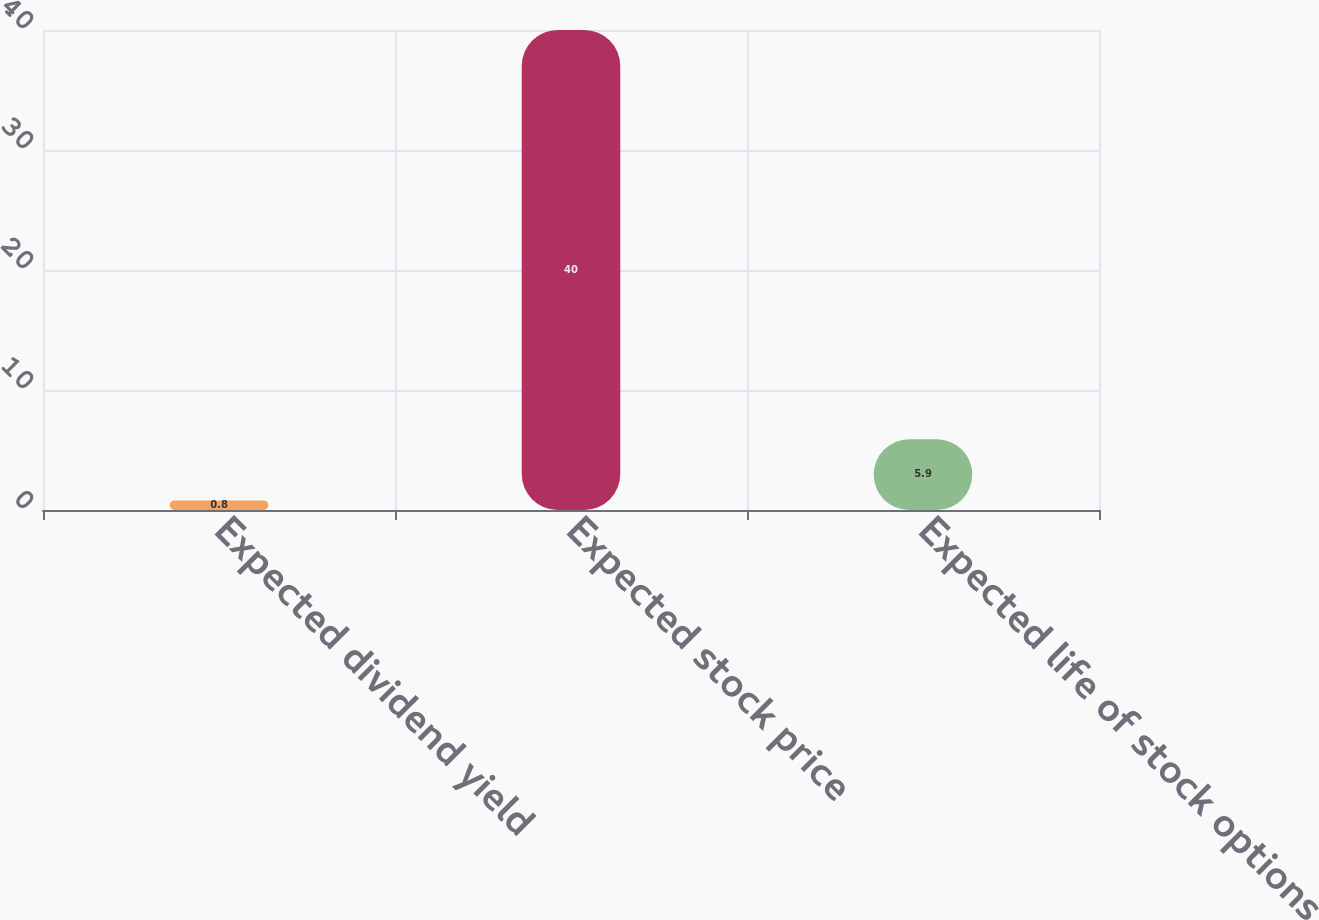Convert chart to OTSL. <chart><loc_0><loc_0><loc_500><loc_500><bar_chart><fcel>Expected dividend yield<fcel>Expected stock price<fcel>Expected life of stock options<nl><fcel>0.8<fcel>40<fcel>5.9<nl></chart> 